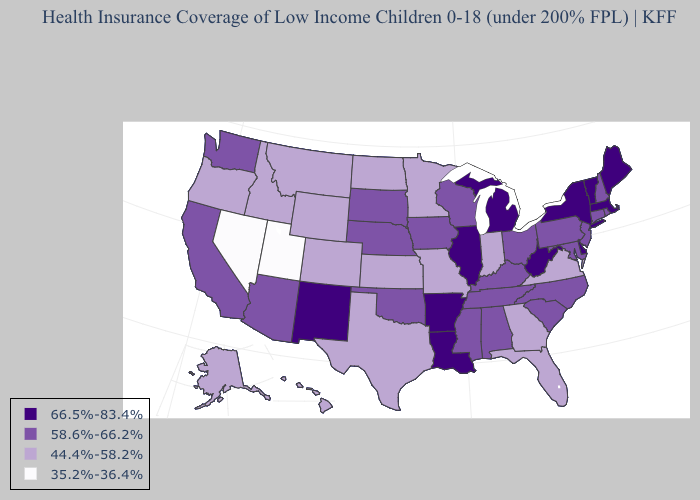What is the highest value in the USA?
Keep it brief. 66.5%-83.4%. Among the states that border Nevada , which have the lowest value?
Quick response, please. Utah. Name the states that have a value in the range 66.5%-83.4%?
Write a very short answer. Arkansas, Delaware, Illinois, Louisiana, Maine, Massachusetts, Michigan, New Mexico, New York, Vermont, West Virginia. What is the highest value in the South ?
Short answer required. 66.5%-83.4%. Name the states that have a value in the range 35.2%-36.4%?
Keep it brief. Nevada, Utah. What is the lowest value in states that border Arkansas?
Quick response, please. 44.4%-58.2%. Name the states that have a value in the range 35.2%-36.4%?
Give a very brief answer. Nevada, Utah. Name the states that have a value in the range 66.5%-83.4%?
Write a very short answer. Arkansas, Delaware, Illinois, Louisiana, Maine, Massachusetts, Michigan, New Mexico, New York, Vermont, West Virginia. What is the lowest value in the Northeast?
Concise answer only. 58.6%-66.2%. What is the highest value in the USA?
Quick response, please. 66.5%-83.4%. What is the value of Utah?
Keep it brief. 35.2%-36.4%. What is the value of Connecticut?
Write a very short answer. 58.6%-66.2%. Which states have the highest value in the USA?
Concise answer only. Arkansas, Delaware, Illinois, Louisiana, Maine, Massachusetts, Michigan, New Mexico, New York, Vermont, West Virginia. What is the lowest value in states that border Connecticut?
Be succinct. 58.6%-66.2%. Does the map have missing data?
Answer briefly. No. 